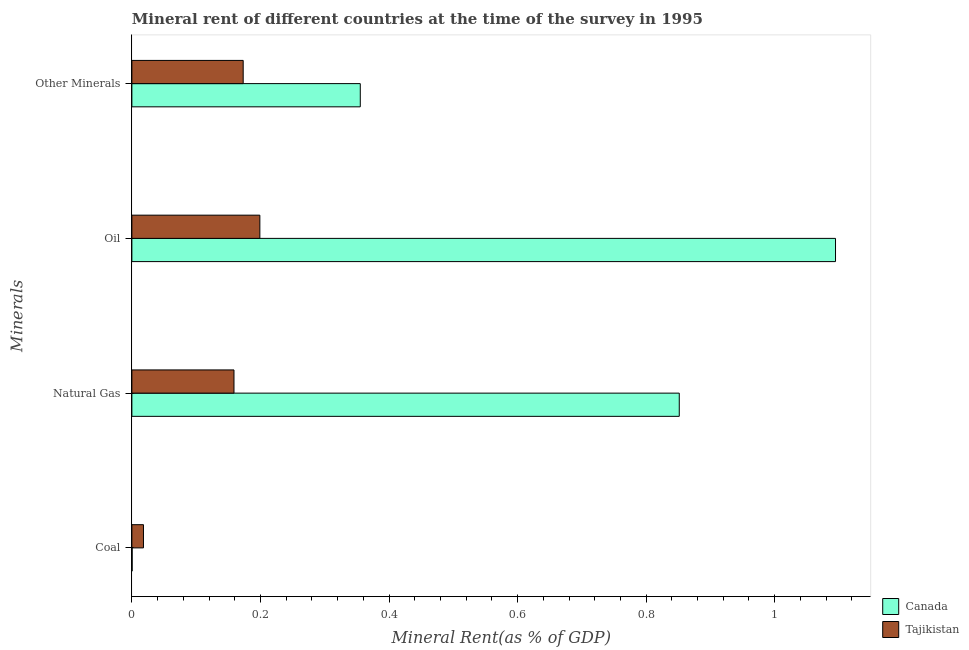How many groups of bars are there?
Offer a very short reply. 4. How many bars are there on the 2nd tick from the bottom?
Keep it short and to the point. 2. What is the label of the 2nd group of bars from the top?
Provide a succinct answer. Oil. What is the natural gas rent in Tajikistan?
Provide a succinct answer. 0.16. Across all countries, what is the maximum oil rent?
Provide a succinct answer. 1.09. Across all countries, what is the minimum  rent of other minerals?
Your answer should be very brief. 0.17. In which country was the oil rent maximum?
Give a very brief answer. Canada. In which country was the  rent of other minerals minimum?
Make the answer very short. Tajikistan. What is the total oil rent in the graph?
Your response must be concise. 1.29. What is the difference between the oil rent in Canada and that in Tajikistan?
Provide a short and direct response. 0.9. What is the difference between the oil rent in Canada and the  rent of other minerals in Tajikistan?
Your answer should be compact. 0.92. What is the average natural gas rent per country?
Keep it short and to the point. 0.51. What is the difference between the natural gas rent and coal rent in Tajikistan?
Offer a very short reply. 0.14. What is the ratio of the natural gas rent in Canada to that in Tajikistan?
Offer a terse response. 5.36. Is the natural gas rent in Canada less than that in Tajikistan?
Your response must be concise. No. Is the difference between the natural gas rent in Canada and Tajikistan greater than the difference between the oil rent in Canada and Tajikistan?
Provide a succinct answer. No. What is the difference between the highest and the second highest oil rent?
Give a very brief answer. 0.9. What is the difference between the highest and the lowest natural gas rent?
Provide a short and direct response. 0.69. In how many countries, is the oil rent greater than the average oil rent taken over all countries?
Make the answer very short. 1. Is it the case that in every country, the sum of the coal rent and natural gas rent is greater than the sum of oil rent and  rent of other minerals?
Offer a terse response. No. What does the 2nd bar from the top in Coal represents?
Give a very brief answer. Canada. What does the 1st bar from the bottom in Natural Gas represents?
Offer a very short reply. Canada. How many bars are there?
Your answer should be very brief. 8. Are all the bars in the graph horizontal?
Provide a succinct answer. Yes. What is the difference between two consecutive major ticks on the X-axis?
Your answer should be very brief. 0.2. Are the values on the major ticks of X-axis written in scientific E-notation?
Your answer should be compact. No. How many legend labels are there?
Provide a succinct answer. 2. What is the title of the graph?
Give a very brief answer. Mineral rent of different countries at the time of the survey in 1995. Does "Guam" appear as one of the legend labels in the graph?
Give a very brief answer. No. What is the label or title of the X-axis?
Offer a terse response. Mineral Rent(as % of GDP). What is the label or title of the Y-axis?
Your response must be concise. Minerals. What is the Mineral Rent(as % of GDP) of Canada in Coal?
Your answer should be compact. 0. What is the Mineral Rent(as % of GDP) in Tajikistan in Coal?
Provide a short and direct response. 0.02. What is the Mineral Rent(as % of GDP) in Canada in Natural Gas?
Your answer should be compact. 0.85. What is the Mineral Rent(as % of GDP) in Tajikistan in Natural Gas?
Offer a very short reply. 0.16. What is the Mineral Rent(as % of GDP) of Canada in Oil?
Keep it short and to the point. 1.09. What is the Mineral Rent(as % of GDP) in Tajikistan in Oil?
Your answer should be very brief. 0.2. What is the Mineral Rent(as % of GDP) in Canada in Other Minerals?
Offer a very short reply. 0.36. What is the Mineral Rent(as % of GDP) of Tajikistan in Other Minerals?
Ensure brevity in your answer.  0.17. Across all Minerals, what is the maximum Mineral Rent(as % of GDP) of Canada?
Your response must be concise. 1.09. Across all Minerals, what is the maximum Mineral Rent(as % of GDP) of Tajikistan?
Provide a short and direct response. 0.2. Across all Minerals, what is the minimum Mineral Rent(as % of GDP) in Canada?
Provide a succinct answer. 0. Across all Minerals, what is the minimum Mineral Rent(as % of GDP) in Tajikistan?
Keep it short and to the point. 0.02. What is the total Mineral Rent(as % of GDP) of Canada in the graph?
Ensure brevity in your answer.  2.3. What is the total Mineral Rent(as % of GDP) of Tajikistan in the graph?
Provide a short and direct response. 0.55. What is the difference between the Mineral Rent(as % of GDP) in Canada in Coal and that in Natural Gas?
Your response must be concise. -0.85. What is the difference between the Mineral Rent(as % of GDP) in Tajikistan in Coal and that in Natural Gas?
Offer a terse response. -0.14. What is the difference between the Mineral Rent(as % of GDP) in Canada in Coal and that in Oil?
Provide a short and direct response. -1.09. What is the difference between the Mineral Rent(as % of GDP) of Tajikistan in Coal and that in Oil?
Your response must be concise. -0.18. What is the difference between the Mineral Rent(as % of GDP) of Canada in Coal and that in Other Minerals?
Your answer should be very brief. -0.35. What is the difference between the Mineral Rent(as % of GDP) of Tajikistan in Coal and that in Other Minerals?
Make the answer very short. -0.16. What is the difference between the Mineral Rent(as % of GDP) in Canada in Natural Gas and that in Oil?
Give a very brief answer. -0.24. What is the difference between the Mineral Rent(as % of GDP) of Tajikistan in Natural Gas and that in Oil?
Your response must be concise. -0.04. What is the difference between the Mineral Rent(as % of GDP) in Canada in Natural Gas and that in Other Minerals?
Your response must be concise. 0.5. What is the difference between the Mineral Rent(as % of GDP) in Tajikistan in Natural Gas and that in Other Minerals?
Offer a very short reply. -0.01. What is the difference between the Mineral Rent(as % of GDP) in Canada in Oil and that in Other Minerals?
Give a very brief answer. 0.74. What is the difference between the Mineral Rent(as % of GDP) of Tajikistan in Oil and that in Other Minerals?
Make the answer very short. 0.03. What is the difference between the Mineral Rent(as % of GDP) of Canada in Coal and the Mineral Rent(as % of GDP) of Tajikistan in Natural Gas?
Offer a terse response. -0.16. What is the difference between the Mineral Rent(as % of GDP) of Canada in Coal and the Mineral Rent(as % of GDP) of Tajikistan in Oil?
Give a very brief answer. -0.2. What is the difference between the Mineral Rent(as % of GDP) of Canada in Coal and the Mineral Rent(as % of GDP) of Tajikistan in Other Minerals?
Provide a succinct answer. -0.17. What is the difference between the Mineral Rent(as % of GDP) of Canada in Natural Gas and the Mineral Rent(as % of GDP) of Tajikistan in Oil?
Your answer should be very brief. 0.65. What is the difference between the Mineral Rent(as % of GDP) in Canada in Natural Gas and the Mineral Rent(as % of GDP) in Tajikistan in Other Minerals?
Offer a terse response. 0.68. What is the difference between the Mineral Rent(as % of GDP) in Canada in Oil and the Mineral Rent(as % of GDP) in Tajikistan in Other Minerals?
Ensure brevity in your answer.  0.92. What is the average Mineral Rent(as % of GDP) in Canada per Minerals?
Offer a terse response. 0.58. What is the average Mineral Rent(as % of GDP) of Tajikistan per Minerals?
Give a very brief answer. 0.14. What is the difference between the Mineral Rent(as % of GDP) of Canada and Mineral Rent(as % of GDP) of Tajikistan in Coal?
Keep it short and to the point. -0.02. What is the difference between the Mineral Rent(as % of GDP) in Canada and Mineral Rent(as % of GDP) in Tajikistan in Natural Gas?
Your answer should be compact. 0.69. What is the difference between the Mineral Rent(as % of GDP) of Canada and Mineral Rent(as % of GDP) of Tajikistan in Oil?
Provide a short and direct response. 0.9. What is the difference between the Mineral Rent(as % of GDP) of Canada and Mineral Rent(as % of GDP) of Tajikistan in Other Minerals?
Provide a succinct answer. 0.18. What is the ratio of the Mineral Rent(as % of GDP) in Tajikistan in Coal to that in Natural Gas?
Offer a terse response. 0.11. What is the ratio of the Mineral Rent(as % of GDP) in Tajikistan in Coal to that in Oil?
Give a very brief answer. 0.09. What is the ratio of the Mineral Rent(as % of GDP) in Canada in Coal to that in Other Minerals?
Your answer should be very brief. 0. What is the ratio of the Mineral Rent(as % of GDP) of Tajikistan in Coal to that in Other Minerals?
Your response must be concise. 0.1. What is the ratio of the Mineral Rent(as % of GDP) in Canada in Natural Gas to that in Oil?
Your answer should be compact. 0.78. What is the ratio of the Mineral Rent(as % of GDP) in Tajikistan in Natural Gas to that in Oil?
Your answer should be compact. 0.8. What is the ratio of the Mineral Rent(as % of GDP) in Canada in Natural Gas to that in Other Minerals?
Keep it short and to the point. 2.4. What is the ratio of the Mineral Rent(as % of GDP) of Tajikistan in Natural Gas to that in Other Minerals?
Your answer should be compact. 0.92. What is the ratio of the Mineral Rent(as % of GDP) of Canada in Oil to that in Other Minerals?
Offer a terse response. 3.08. What is the ratio of the Mineral Rent(as % of GDP) of Tajikistan in Oil to that in Other Minerals?
Your response must be concise. 1.15. What is the difference between the highest and the second highest Mineral Rent(as % of GDP) of Canada?
Give a very brief answer. 0.24. What is the difference between the highest and the second highest Mineral Rent(as % of GDP) in Tajikistan?
Your answer should be very brief. 0.03. What is the difference between the highest and the lowest Mineral Rent(as % of GDP) of Canada?
Provide a succinct answer. 1.09. What is the difference between the highest and the lowest Mineral Rent(as % of GDP) in Tajikistan?
Ensure brevity in your answer.  0.18. 